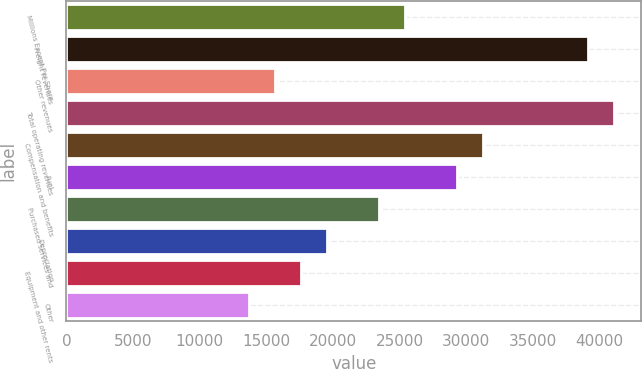Convert chart. <chart><loc_0><loc_0><loc_500><loc_500><bar_chart><fcel>Millions Except Per Share<fcel>Freight revenues<fcel>Other revenues<fcel>Total operating revenues<fcel>Compensation and benefits<fcel>Fuel<fcel>Purchased services and<fcel>Depreciation<fcel>Equipment and other rents<fcel>Other<nl><fcel>25423.6<fcel>39112.1<fcel>15646<fcel>41067.6<fcel>31290.1<fcel>29334.6<fcel>23468<fcel>19557<fcel>17601.5<fcel>13690.5<nl></chart> 